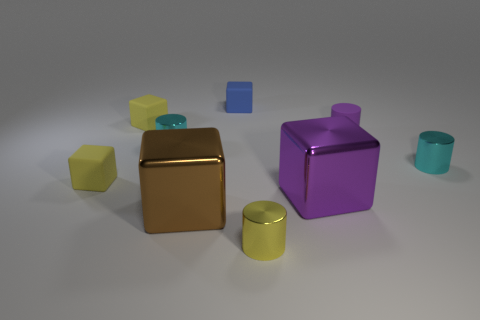How many objects are there, and can they be categorized? There are seven objects in total, which we can categorize based on their shapes: there are cubes, cylinders, and what appears to be a rectangular prism. These objects are assorted in color as well, further diversifying their classifications. 